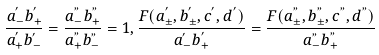Convert formula to latex. <formula><loc_0><loc_0><loc_500><loc_500>\frac { a _ { - } ^ { ^ { \prime } } b _ { + } ^ { ^ { \prime } } } { a _ { + } ^ { ^ { \prime } } b _ { - } ^ { ^ { \prime } } } = \frac { a _ { - } ^ { " } b _ { + } ^ { " } } { a _ { + } ^ { " } b _ { - } ^ { " } } = 1 , \frac { F ( a _ { \pm } ^ { ^ { \prime } } , b _ { \pm } ^ { ^ { \prime } } , c ^ { ^ { \prime } } , d ^ { ^ { \prime } } ) } { a _ { - } ^ { ^ { \prime } } b _ { + } ^ { ^ { \prime } } } = \frac { F ( a _ { \pm } ^ { " } , b _ { \pm } ^ { " } , c ^ { " } , d ^ { " } ) } { a _ { - } ^ { " } b _ { + } ^ { " } }</formula> 